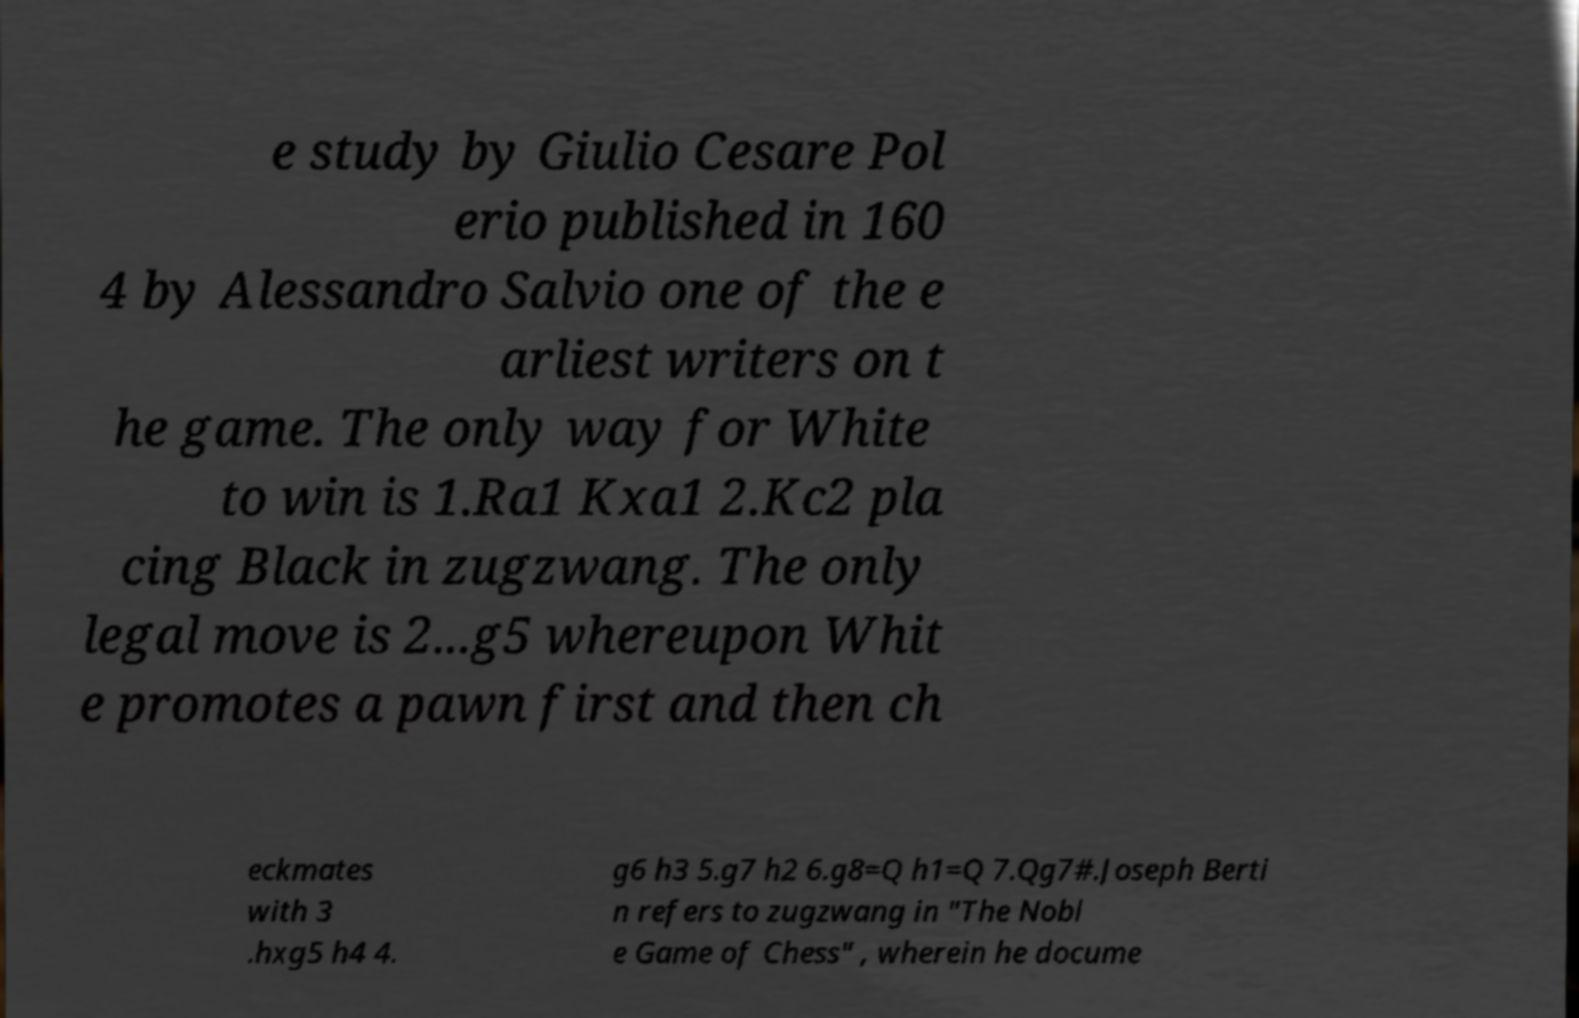Can you accurately transcribe the text from the provided image for me? e study by Giulio Cesare Pol erio published in 160 4 by Alessandro Salvio one of the e arliest writers on t he game. The only way for White to win is 1.Ra1 Kxa1 2.Kc2 pla cing Black in zugzwang. The only legal move is 2...g5 whereupon Whit e promotes a pawn first and then ch eckmates with 3 .hxg5 h4 4. g6 h3 5.g7 h2 6.g8=Q h1=Q 7.Qg7#.Joseph Berti n refers to zugzwang in "The Nobl e Game of Chess" , wherein he docume 